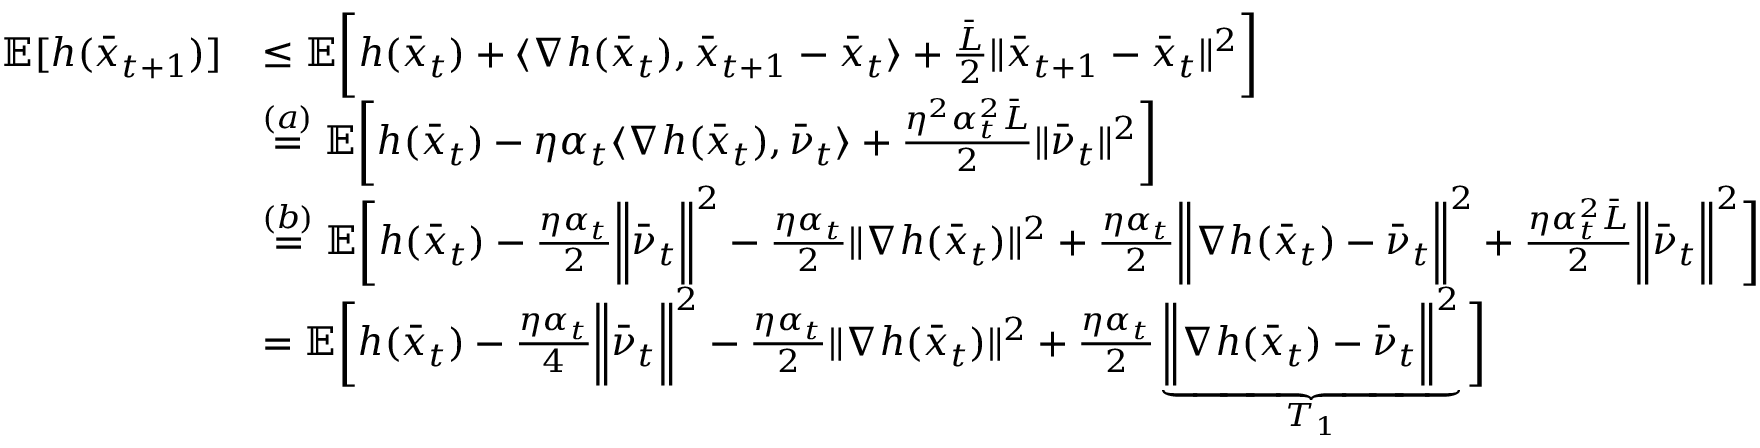Convert formula to latex. <formula><loc_0><loc_0><loc_500><loc_500>\begin{array} { r l } { \mathbb { E } [ h ( \bar { x } _ { t + 1 } ) ] } & { \leq \mathbb { E } \left [ h ( \bar { x } _ { t } ) + \langle \nabla h ( \bar { x } _ { t } ) , \bar { x } _ { t + 1 } - \bar { x } _ { t } \rangle + \frac { \bar { L } } { 2 } \| \bar { x } _ { t + 1 } - \bar { x } _ { t } \| ^ { 2 } \right ] } \\ & { \overset { ( a ) } { = } \mathbb { E } \left [ h ( \bar { x } _ { t } ) - \eta \alpha _ { t } \langle \nabla h ( \bar { x } _ { t } ) , \bar { \nu } _ { t } \rangle + \frac { \eta ^ { 2 } \alpha _ { t } ^ { 2 } \bar { L } } { 2 } \| \bar { \nu } _ { t } \| ^ { 2 } \right ] } \\ & { \overset { ( b ) } { = } \mathbb { E } \left [ h ( \bar { x } _ { t } ) - \frac { \eta \alpha _ { t } } { 2 } \left \| \bar { \nu } _ { t } \right \| ^ { 2 } - \frac { \eta \alpha _ { t } } { 2 } \| \nabla h ( \bar { x } _ { t } ) \| ^ { 2 } + \frac { \eta \alpha _ { t } } { 2 } \left \| \nabla h ( \bar { x } _ { t } ) - \bar { \nu } _ { t } \right \| ^ { 2 } + \frac { \eta \alpha _ { t } ^ { 2 } \bar { L } } { 2 } \left \| \bar { \nu } _ { t } \right \| ^ { 2 } \right ] } \\ & { = \mathbb { E } \left [ h ( \bar { x } _ { t } ) - \frac { \eta \alpha _ { t } } { 4 } \left \| \bar { \nu } _ { t } \right \| ^ { 2 } - \frac { \eta \alpha _ { t } } { 2 } \| \nabla h ( \bar { x } _ { t } ) \| ^ { 2 } + \frac { \eta \alpha _ { t } } { 2 } \underbrace { \left \| \nabla h ( \bar { x } _ { t } ) - \bar { \nu } _ { t } \right \| ^ { 2 } } _ { T _ { 1 } } \right ] } \end{array}</formula> 